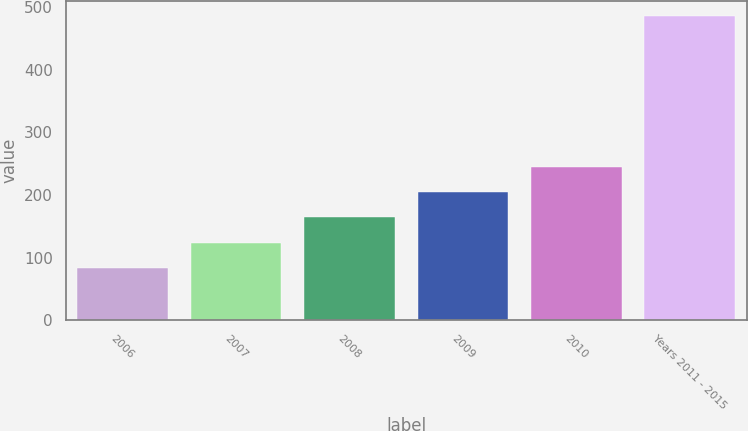Convert chart. <chart><loc_0><loc_0><loc_500><loc_500><bar_chart><fcel>2006<fcel>2007<fcel>2008<fcel>2009<fcel>2010<fcel>Years 2011 - 2015<nl><fcel>84<fcel>124.1<fcel>164.2<fcel>204.3<fcel>244.4<fcel>485<nl></chart> 